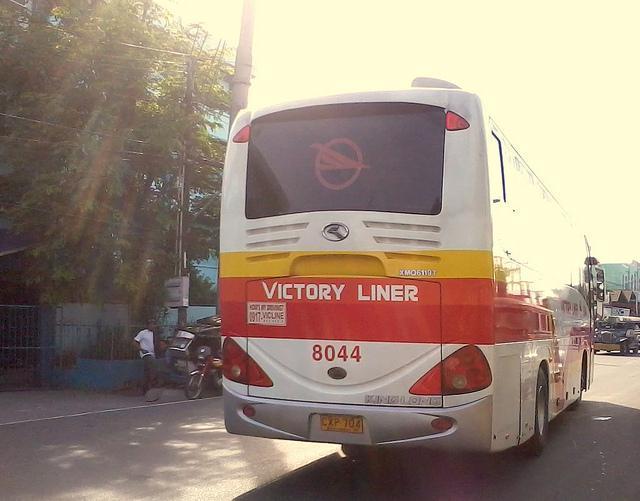How many rolls of toilet paper are on top of the toilet?
Give a very brief answer. 0. 